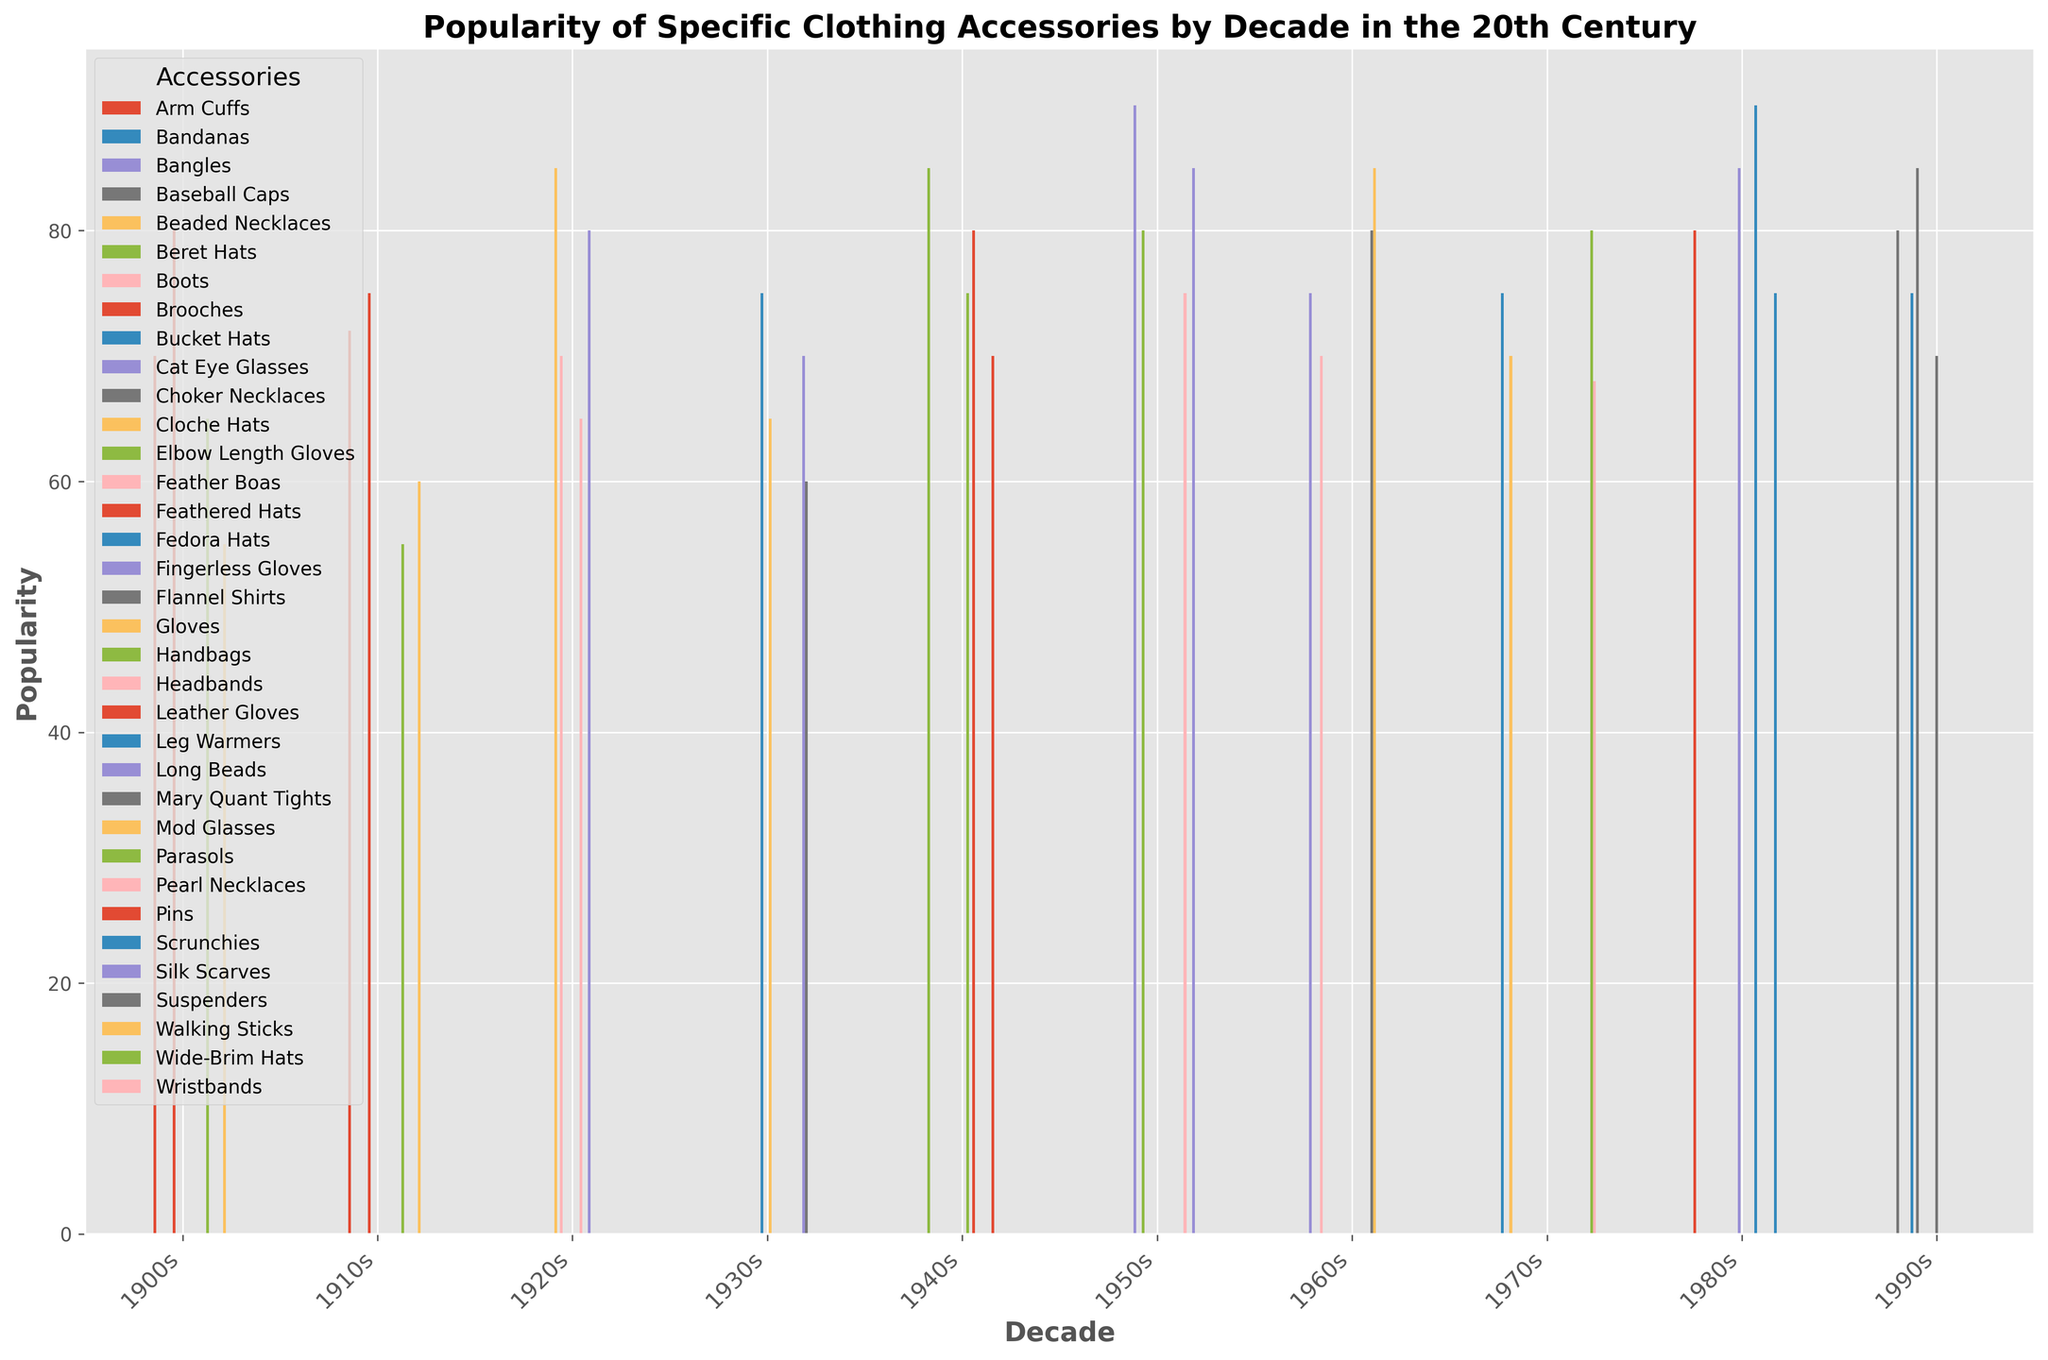Which accessory had the highest popularity in the 1950s? By observing the bar heights in the "1950s" section, we see the "Cat Eye Glasses" bar is the tallest.
Answer: Cat Eye Glasses How did the popularity of Feathered Hats change from the 1900s to the 1920s? In the 1900s, Feathered Hats had a popularity of 80. In the 1920s, Feathered Hats' popularity is not listed, indicating they were not among the top accessories.
Answer: Dropped to zero What was the average popularity of accessories in the 1980s? The popularity values for the 1980s are 90 (Leg Warmers), 85 (Fingerless Gloves), 80 (Arm Cuffs), and 75 (Scrunchies). Sum: 90 + 85 + 80 + 75 = 330. Average: 330 / 4 = 82.5
Answer: 82.5 Which decade had the highest variability in accessory popularity? The 1990s have popularity values of 85, 80, 75, and 70. The range (highest - lowest) for 1990s is 85 - 70 = 15. Check and compare for other decades.
Answer: 1980s Compare the popularity of Brooches in the 1900s to the 1910s. Which decade was it more popular? In the 1900s, Brooches had a popularity of 70. In the 1910s, it was 72.
Answer: 1910s Which accessory was most consistently popular across the decades? Observe if any accessories are consistently high or vary less across the decades. Accessories like "Feathered Hats" and "Silk Scarves" can be contenders.
Answer: Silk Scarves By how much did the popularity of Gloves change from the 1930s to the 1950s? In the 1930s, Gloves had 65 popularity. In the 1950s, Elbow Length Gloves had 80 popularity. Difference: 80 - 65 = 15.
Answer: Increased by 15 In which decade did hats overall have the most variety in styles? Look for decades with multiple different types of hats noted, each with popularity values.
Answer: 1940s What's the sum of popularity values for accessories in the 1910s? The popularity values are 75 (Feathered Hats), 72 (Brooches), 55 (Parasols), 60 (Walking Sticks). Sum: 75 + 72 + 55 + 60 = 262
Answer: 262 Which decade had only one accessory crossing the 80 popularity mark? Observe the bars for values crossing 80. The 1960s only have Mod Glasses (85) and Mary Quant Tights at 80, not crossing it.
Answer: 1960s 